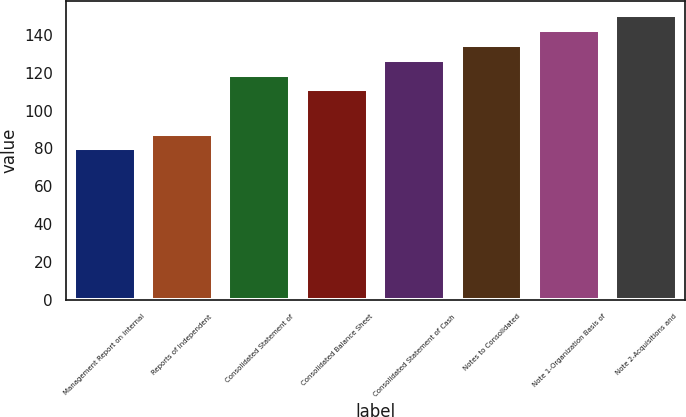<chart> <loc_0><loc_0><loc_500><loc_500><bar_chart><fcel>Management Report on Internal<fcel>Reports of Independent<fcel>Consolidated Statement of<fcel>Consolidated Balance Sheet<fcel>Consolidated Statement of Cash<fcel>Notes to Consolidated<fcel>Note 1-Organization Basis of<fcel>Note 2-Acquisitions and<nl><fcel>80<fcel>87.8<fcel>119<fcel>111.2<fcel>126.8<fcel>134.6<fcel>142.4<fcel>150.2<nl></chart> 